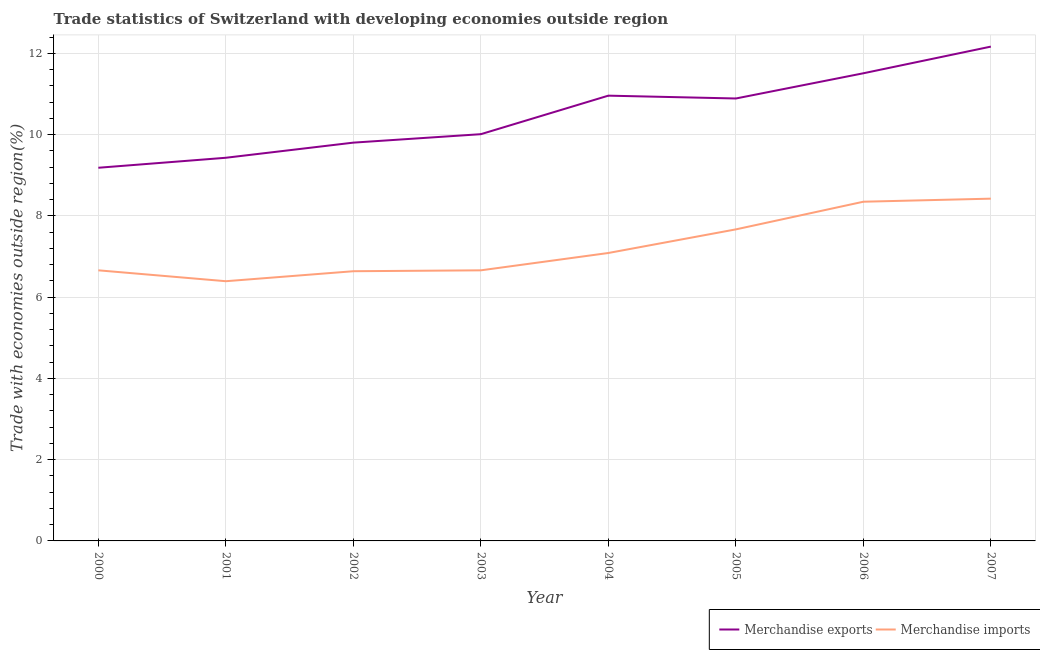Does the line corresponding to merchandise exports intersect with the line corresponding to merchandise imports?
Offer a terse response. No. Is the number of lines equal to the number of legend labels?
Make the answer very short. Yes. What is the merchandise exports in 2006?
Keep it short and to the point. 11.51. Across all years, what is the maximum merchandise exports?
Provide a succinct answer. 12.17. Across all years, what is the minimum merchandise imports?
Offer a very short reply. 6.39. In which year was the merchandise imports maximum?
Provide a succinct answer. 2007. In which year was the merchandise exports minimum?
Provide a short and direct response. 2000. What is the total merchandise exports in the graph?
Offer a very short reply. 83.96. What is the difference between the merchandise imports in 2000 and that in 2002?
Keep it short and to the point. 0.02. What is the difference between the merchandise exports in 2003 and the merchandise imports in 2006?
Offer a terse response. 1.66. What is the average merchandise exports per year?
Keep it short and to the point. 10.49. In the year 2004, what is the difference between the merchandise imports and merchandise exports?
Make the answer very short. -3.87. In how many years, is the merchandise exports greater than 7.2 %?
Ensure brevity in your answer.  8. What is the ratio of the merchandise exports in 2005 to that in 2007?
Your response must be concise. 0.9. What is the difference between the highest and the second highest merchandise exports?
Offer a terse response. 0.66. What is the difference between the highest and the lowest merchandise imports?
Provide a short and direct response. 2.03. In how many years, is the merchandise imports greater than the average merchandise imports taken over all years?
Make the answer very short. 3. Is the sum of the merchandise exports in 2001 and 2007 greater than the maximum merchandise imports across all years?
Your answer should be compact. Yes. Is the merchandise exports strictly greater than the merchandise imports over the years?
Offer a terse response. Yes. How many lines are there?
Your response must be concise. 2. How many years are there in the graph?
Ensure brevity in your answer.  8. What is the title of the graph?
Make the answer very short. Trade statistics of Switzerland with developing economies outside region. What is the label or title of the X-axis?
Your answer should be compact. Year. What is the label or title of the Y-axis?
Your answer should be compact. Trade with economies outside region(%). What is the Trade with economies outside region(%) in Merchandise exports in 2000?
Offer a terse response. 9.18. What is the Trade with economies outside region(%) in Merchandise imports in 2000?
Ensure brevity in your answer.  6.66. What is the Trade with economies outside region(%) in Merchandise exports in 2001?
Your answer should be compact. 9.43. What is the Trade with economies outside region(%) in Merchandise imports in 2001?
Provide a short and direct response. 6.39. What is the Trade with economies outside region(%) of Merchandise exports in 2002?
Give a very brief answer. 9.8. What is the Trade with economies outside region(%) in Merchandise imports in 2002?
Make the answer very short. 6.64. What is the Trade with economies outside region(%) of Merchandise exports in 2003?
Ensure brevity in your answer.  10.01. What is the Trade with economies outside region(%) in Merchandise imports in 2003?
Your answer should be very brief. 6.66. What is the Trade with economies outside region(%) in Merchandise exports in 2004?
Make the answer very short. 10.96. What is the Trade with economies outside region(%) of Merchandise imports in 2004?
Your answer should be compact. 7.09. What is the Trade with economies outside region(%) in Merchandise exports in 2005?
Provide a short and direct response. 10.89. What is the Trade with economies outside region(%) of Merchandise imports in 2005?
Your response must be concise. 7.67. What is the Trade with economies outside region(%) in Merchandise exports in 2006?
Your answer should be very brief. 11.51. What is the Trade with economies outside region(%) in Merchandise imports in 2006?
Provide a short and direct response. 8.35. What is the Trade with economies outside region(%) in Merchandise exports in 2007?
Make the answer very short. 12.17. What is the Trade with economies outside region(%) of Merchandise imports in 2007?
Offer a terse response. 8.42. Across all years, what is the maximum Trade with economies outside region(%) in Merchandise exports?
Keep it short and to the point. 12.17. Across all years, what is the maximum Trade with economies outside region(%) in Merchandise imports?
Give a very brief answer. 8.42. Across all years, what is the minimum Trade with economies outside region(%) in Merchandise exports?
Provide a short and direct response. 9.18. Across all years, what is the minimum Trade with economies outside region(%) of Merchandise imports?
Offer a terse response. 6.39. What is the total Trade with economies outside region(%) of Merchandise exports in the graph?
Provide a short and direct response. 83.96. What is the total Trade with economies outside region(%) in Merchandise imports in the graph?
Offer a very short reply. 57.88. What is the difference between the Trade with economies outside region(%) of Merchandise exports in 2000 and that in 2001?
Make the answer very short. -0.25. What is the difference between the Trade with economies outside region(%) of Merchandise imports in 2000 and that in 2001?
Provide a short and direct response. 0.27. What is the difference between the Trade with economies outside region(%) in Merchandise exports in 2000 and that in 2002?
Your answer should be very brief. -0.62. What is the difference between the Trade with economies outside region(%) in Merchandise imports in 2000 and that in 2002?
Your answer should be very brief. 0.02. What is the difference between the Trade with economies outside region(%) in Merchandise exports in 2000 and that in 2003?
Keep it short and to the point. -0.83. What is the difference between the Trade with economies outside region(%) of Merchandise exports in 2000 and that in 2004?
Your answer should be very brief. -1.77. What is the difference between the Trade with economies outside region(%) of Merchandise imports in 2000 and that in 2004?
Offer a very short reply. -0.43. What is the difference between the Trade with economies outside region(%) of Merchandise exports in 2000 and that in 2005?
Provide a short and direct response. -1.71. What is the difference between the Trade with economies outside region(%) in Merchandise imports in 2000 and that in 2005?
Give a very brief answer. -1.01. What is the difference between the Trade with economies outside region(%) in Merchandise exports in 2000 and that in 2006?
Your answer should be compact. -2.33. What is the difference between the Trade with economies outside region(%) of Merchandise imports in 2000 and that in 2006?
Your response must be concise. -1.69. What is the difference between the Trade with economies outside region(%) of Merchandise exports in 2000 and that in 2007?
Make the answer very short. -2.98. What is the difference between the Trade with economies outside region(%) of Merchandise imports in 2000 and that in 2007?
Provide a short and direct response. -1.76. What is the difference between the Trade with economies outside region(%) in Merchandise exports in 2001 and that in 2002?
Offer a very short reply. -0.37. What is the difference between the Trade with economies outside region(%) in Merchandise imports in 2001 and that in 2002?
Your answer should be compact. -0.25. What is the difference between the Trade with economies outside region(%) in Merchandise exports in 2001 and that in 2003?
Keep it short and to the point. -0.58. What is the difference between the Trade with economies outside region(%) in Merchandise imports in 2001 and that in 2003?
Give a very brief answer. -0.27. What is the difference between the Trade with economies outside region(%) of Merchandise exports in 2001 and that in 2004?
Give a very brief answer. -1.53. What is the difference between the Trade with economies outside region(%) of Merchandise imports in 2001 and that in 2004?
Make the answer very short. -0.69. What is the difference between the Trade with economies outside region(%) in Merchandise exports in 2001 and that in 2005?
Your response must be concise. -1.46. What is the difference between the Trade with economies outside region(%) in Merchandise imports in 2001 and that in 2005?
Offer a terse response. -1.28. What is the difference between the Trade with economies outside region(%) of Merchandise exports in 2001 and that in 2006?
Provide a short and direct response. -2.08. What is the difference between the Trade with economies outside region(%) in Merchandise imports in 2001 and that in 2006?
Keep it short and to the point. -1.96. What is the difference between the Trade with economies outside region(%) of Merchandise exports in 2001 and that in 2007?
Your answer should be compact. -2.74. What is the difference between the Trade with economies outside region(%) of Merchandise imports in 2001 and that in 2007?
Make the answer very short. -2.03. What is the difference between the Trade with economies outside region(%) in Merchandise exports in 2002 and that in 2003?
Your response must be concise. -0.21. What is the difference between the Trade with economies outside region(%) in Merchandise imports in 2002 and that in 2003?
Ensure brevity in your answer.  -0.02. What is the difference between the Trade with economies outside region(%) of Merchandise exports in 2002 and that in 2004?
Provide a succinct answer. -1.16. What is the difference between the Trade with economies outside region(%) of Merchandise imports in 2002 and that in 2004?
Offer a very short reply. -0.45. What is the difference between the Trade with economies outside region(%) in Merchandise exports in 2002 and that in 2005?
Your answer should be very brief. -1.09. What is the difference between the Trade with economies outside region(%) in Merchandise imports in 2002 and that in 2005?
Give a very brief answer. -1.03. What is the difference between the Trade with economies outside region(%) of Merchandise exports in 2002 and that in 2006?
Your answer should be very brief. -1.71. What is the difference between the Trade with economies outside region(%) of Merchandise imports in 2002 and that in 2006?
Provide a short and direct response. -1.71. What is the difference between the Trade with economies outside region(%) of Merchandise exports in 2002 and that in 2007?
Your answer should be compact. -2.36. What is the difference between the Trade with economies outside region(%) of Merchandise imports in 2002 and that in 2007?
Offer a very short reply. -1.79. What is the difference between the Trade with economies outside region(%) in Merchandise exports in 2003 and that in 2004?
Your response must be concise. -0.95. What is the difference between the Trade with economies outside region(%) of Merchandise imports in 2003 and that in 2004?
Provide a succinct answer. -0.43. What is the difference between the Trade with economies outside region(%) in Merchandise exports in 2003 and that in 2005?
Your answer should be compact. -0.88. What is the difference between the Trade with economies outside region(%) in Merchandise imports in 2003 and that in 2005?
Offer a terse response. -1.01. What is the difference between the Trade with economies outside region(%) in Merchandise exports in 2003 and that in 2006?
Ensure brevity in your answer.  -1.5. What is the difference between the Trade with economies outside region(%) of Merchandise imports in 2003 and that in 2006?
Your answer should be very brief. -1.69. What is the difference between the Trade with economies outside region(%) in Merchandise exports in 2003 and that in 2007?
Ensure brevity in your answer.  -2.16. What is the difference between the Trade with economies outside region(%) in Merchandise imports in 2003 and that in 2007?
Provide a short and direct response. -1.76. What is the difference between the Trade with economies outside region(%) of Merchandise exports in 2004 and that in 2005?
Make the answer very short. 0.07. What is the difference between the Trade with economies outside region(%) in Merchandise imports in 2004 and that in 2005?
Give a very brief answer. -0.58. What is the difference between the Trade with economies outside region(%) in Merchandise exports in 2004 and that in 2006?
Offer a terse response. -0.55. What is the difference between the Trade with economies outside region(%) of Merchandise imports in 2004 and that in 2006?
Offer a terse response. -1.26. What is the difference between the Trade with economies outside region(%) in Merchandise exports in 2004 and that in 2007?
Keep it short and to the point. -1.21. What is the difference between the Trade with economies outside region(%) of Merchandise imports in 2004 and that in 2007?
Ensure brevity in your answer.  -1.34. What is the difference between the Trade with economies outside region(%) in Merchandise exports in 2005 and that in 2006?
Your response must be concise. -0.62. What is the difference between the Trade with economies outside region(%) of Merchandise imports in 2005 and that in 2006?
Your answer should be very brief. -0.68. What is the difference between the Trade with economies outside region(%) of Merchandise exports in 2005 and that in 2007?
Offer a terse response. -1.28. What is the difference between the Trade with economies outside region(%) of Merchandise imports in 2005 and that in 2007?
Your answer should be very brief. -0.76. What is the difference between the Trade with economies outside region(%) in Merchandise exports in 2006 and that in 2007?
Ensure brevity in your answer.  -0.66. What is the difference between the Trade with economies outside region(%) in Merchandise imports in 2006 and that in 2007?
Your answer should be very brief. -0.08. What is the difference between the Trade with economies outside region(%) of Merchandise exports in 2000 and the Trade with economies outside region(%) of Merchandise imports in 2001?
Offer a terse response. 2.79. What is the difference between the Trade with economies outside region(%) in Merchandise exports in 2000 and the Trade with economies outside region(%) in Merchandise imports in 2002?
Offer a very short reply. 2.55. What is the difference between the Trade with economies outside region(%) of Merchandise exports in 2000 and the Trade with economies outside region(%) of Merchandise imports in 2003?
Offer a very short reply. 2.52. What is the difference between the Trade with economies outside region(%) of Merchandise exports in 2000 and the Trade with economies outside region(%) of Merchandise imports in 2004?
Provide a succinct answer. 2.1. What is the difference between the Trade with economies outside region(%) of Merchandise exports in 2000 and the Trade with economies outside region(%) of Merchandise imports in 2005?
Ensure brevity in your answer.  1.52. What is the difference between the Trade with economies outside region(%) in Merchandise exports in 2000 and the Trade with economies outside region(%) in Merchandise imports in 2006?
Ensure brevity in your answer.  0.84. What is the difference between the Trade with economies outside region(%) in Merchandise exports in 2000 and the Trade with economies outside region(%) in Merchandise imports in 2007?
Your answer should be very brief. 0.76. What is the difference between the Trade with economies outside region(%) in Merchandise exports in 2001 and the Trade with economies outside region(%) in Merchandise imports in 2002?
Offer a terse response. 2.79. What is the difference between the Trade with economies outside region(%) of Merchandise exports in 2001 and the Trade with economies outside region(%) of Merchandise imports in 2003?
Keep it short and to the point. 2.77. What is the difference between the Trade with economies outside region(%) in Merchandise exports in 2001 and the Trade with economies outside region(%) in Merchandise imports in 2004?
Provide a succinct answer. 2.34. What is the difference between the Trade with economies outside region(%) of Merchandise exports in 2001 and the Trade with economies outside region(%) of Merchandise imports in 2005?
Ensure brevity in your answer.  1.76. What is the difference between the Trade with economies outside region(%) of Merchandise exports in 2001 and the Trade with economies outside region(%) of Merchandise imports in 2006?
Offer a very short reply. 1.08. What is the difference between the Trade with economies outside region(%) of Merchandise exports in 2001 and the Trade with economies outside region(%) of Merchandise imports in 2007?
Offer a terse response. 1.01. What is the difference between the Trade with economies outside region(%) of Merchandise exports in 2002 and the Trade with economies outside region(%) of Merchandise imports in 2003?
Give a very brief answer. 3.14. What is the difference between the Trade with economies outside region(%) in Merchandise exports in 2002 and the Trade with economies outside region(%) in Merchandise imports in 2004?
Provide a succinct answer. 2.72. What is the difference between the Trade with economies outside region(%) of Merchandise exports in 2002 and the Trade with economies outside region(%) of Merchandise imports in 2005?
Your answer should be compact. 2.14. What is the difference between the Trade with economies outside region(%) of Merchandise exports in 2002 and the Trade with economies outside region(%) of Merchandise imports in 2006?
Your answer should be compact. 1.45. What is the difference between the Trade with economies outside region(%) of Merchandise exports in 2002 and the Trade with economies outside region(%) of Merchandise imports in 2007?
Keep it short and to the point. 1.38. What is the difference between the Trade with economies outside region(%) in Merchandise exports in 2003 and the Trade with economies outside region(%) in Merchandise imports in 2004?
Your response must be concise. 2.92. What is the difference between the Trade with economies outside region(%) in Merchandise exports in 2003 and the Trade with economies outside region(%) in Merchandise imports in 2005?
Offer a very short reply. 2.34. What is the difference between the Trade with economies outside region(%) in Merchandise exports in 2003 and the Trade with economies outside region(%) in Merchandise imports in 2006?
Keep it short and to the point. 1.66. What is the difference between the Trade with economies outside region(%) of Merchandise exports in 2003 and the Trade with economies outside region(%) of Merchandise imports in 2007?
Ensure brevity in your answer.  1.59. What is the difference between the Trade with economies outside region(%) of Merchandise exports in 2004 and the Trade with economies outside region(%) of Merchandise imports in 2005?
Offer a very short reply. 3.29. What is the difference between the Trade with economies outside region(%) of Merchandise exports in 2004 and the Trade with economies outside region(%) of Merchandise imports in 2006?
Give a very brief answer. 2.61. What is the difference between the Trade with economies outside region(%) in Merchandise exports in 2004 and the Trade with economies outside region(%) in Merchandise imports in 2007?
Offer a terse response. 2.54. What is the difference between the Trade with economies outside region(%) in Merchandise exports in 2005 and the Trade with economies outside region(%) in Merchandise imports in 2006?
Offer a terse response. 2.54. What is the difference between the Trade with economies outside region(%) in Merchandise exports in 2005 and the Trade with economies outside region(%) in Merchandise imports in 2007?
Offer a terse response. 2.47. What is the difference between the Trade with economies outside region(%) in Merchandise exports in 2006 and the Trade with economies outside region(%) in Merchandise imports in 2007?
Your response must be concise. 3.09. What is the average Trade with economies outside region(%) of Merchandise exports per year?
Keep it short and to the point. 10.49. What is the average Trade with economies outside region(%) in Merchandise imports per year?
Your answer should be very brief. 7.23. In the year 2000, what is the difference between the Trade with economies outside region(%) of Merchandise exports and Trade with economies outside region(%) of Merchandise imports?
Your answer should be compact. 2.52. In the year 2001, what is the difference between the Trade with economies outside region(%) of Merchandise exports and Trade with economies outside region(%) of Merchandise imports?
Your response must be concise. 3.04. In the year 2002, what is the difference between the Trade with economies outside region(%) in Merchandise exports and Trade with economies outside region(%) in Merchandise imports?
Offer a very short reply. 3.17. In the year 2003, what is the difference between the Trade with economies outside region(%) in Merchandise exports and Trade with economies outside region(%) in Merchandise imports?
Provide a short and direct response. 3.35. In the year 2004, what is the difference between the Trade with economies outside region(%) in Merchandise exports and Trade with economies outside region(%) in Merchandise imports?
Make the answer very short. 3.87. In the year 2005, what is the difference between the Trade with economies outside region(%) in Merchandise exports and Trade with economies outside region(%) in Merchandise imports?
Your answer should be compact. 3.22. In the year 2006, what is the difference between the Trade with economies outside region(%) in Merchandise exports and Trade with economies outside region(%) in Merchandise imports?
Provide a short and direct response. 3.16. In the year 2007, what is the difference between the Trade with economies outside region(%) of Merchandise exports and Trade with economies outside region(%) of Merchandise imports?
Give a very brief answer. 3.74. What is the ratio of the Trade with economies outside region(%) of Merchandise exports in 2000 to that in 2001?
Provide a succinct answer. 0.97. What is the ratio of the Trade with economies outside region(%) of Merchandise imports in 2000 to that in 2001?
Give a very brief answer. 1.04. What is the ratio of the Trade with economies outside region(%) of Merchandise exports in 2000 to that in 2002?
Your answer should be compact. 0.94. What is the ratio of the Trade with economies outside region(%) of Merchandise imports in 2000 to that in 2002?
Your answer should be compact. 1. What is the ratio of the Trade with economies outside region(%) in Merchandise exports in 2000 to that in 2003?
Your response must be concise. 0.92. What is the ratio of the Trade with economies outside region(%) of Merchandise imports in 2000 to that in 2003?
Provide a short and direct response. 1. What is the ratio of the Trade with economies outside region(%) in Merchandise exports in 2000 to that in 2004?
Provide a succinct answer. 0.84. What is the ratio of the Trade with economies outside region(%) in Merchandise imports in 2000 to that in 2004?
Give a very brief answer. 0.94. What is the ratio of the Trade with economies outside region(%) in Merchandise exports in 2000 to that in 2005?
Provide a short and direct response. 0.84. What is the ratio of the Trade with economies outside region(%) of Merchandise imports in 2000 to that in 2005?
Your response must be concise. 0.87. What is the ratio of the Trade with economies outside region(%) of Merchandise exports in 2000 to that in 2006?
Your answer should be very brief. 0.8. What is the ratio of the Trade with economies outside region(%) in Merchandise imports in 2000 to that in 2006?
Offer a terse response. 0.8. What is the ratio of the Trade with economies outside region(%) in Merchandise exports in 2000 to that in 2007?
Ensure brevity in your answer.  0.75. What is the ratio of the Trade with economies outside region(%) in Merchandise imports in 2000 to that in 2007?
Your response must be concise. 0.79. What is the ratio of the Trade with economies outside region(%) in Merchandise exports in 2001 to that in 2003?
Your answer should be compact. 0.94. What is the ratio of the Trade with economies outside region(%) of Merchandise imports in 2001 to that in 2003?
Provide a succinct answer. 0.96. What is the ratio of the Trade with economies outside region(%) of Merchandise exports in 2001 to that in 2004?
Provide a short and direct response. 0.86. What is the ratio of the Trade with economies outside region(%) of Merchandise imports in 2001 to that in 2004?
Your response must be concise. 0.9. What is the ratio of the Trade with economies outside region(%) of Merchandise exports in 2001 to that in 2005?
Your answer should be very brief. 0.87. What is the ratio of the Trade with economies outside region(%) of Merchandise imports in 2001 to that in 2005?
Ensure brevity in your answer.  0.83. What is the ratio of the Trade with economies outside region(%) in Merchandise exports in 2001 to that in 2006?
Give a very brief answer. 0.82. What is the ratio of the Trade with economies outside region(%) in Merchandise imports in 2001 to that in 2006?
Your response must be concise. 0.77. What is the ratio of the Trade with economies outside region(%) of Merchandise exports in 2001 to that in 2007?
Your answer should be compact. 0.78. What is the ratio of the Trade with economies outside region(%) of Merchandise imports in 2001 to that in 2007?
Ensure brevity in your answer.  0.76. What is the ratio of the Trade with economies outside region(%) in Merchandise exports in 2002 to that in 2003?
Your answer should be very brief. 0.98. What is the ratio of the Trade with economies outside region(%) of Merchandise exports in 2002 to that in 2004?
Keep it short and to the point. 0.89. What is the ratio of the Trade with economies outside region(%) in Merchandise imports in 2002 to that in 2004?
Provide a short and direct response. 0.94. What is the ratio of the Trade with economies outside region(%) in Merchandise exports in 2002 to that in 2005?
Ensure brevity in your answer.  0.9. What is the ratio of the Trade with economies outside region(%) in Merchandise imports in 2002 to that in 2005?
Your answer should be very brief. 0.87. What is the ratio of the Trade with economies outside region(%) in Merchandise exports in 2002 to that in 2006?
Offer a terse response. 0.85. What is the ratio of the Trade with economies outside region(%) of Merchandise imports in 2002 to that in 2006?
Keep it short and to the point. 0.8. What is the ratio of the Trade with economies outside region(%) in Merchandise exports in 2002 to that in 2007?
Provide a succinct answer. 0.81. What is the ratio of the Trade with economies outside region(%) in Merchandise imports in 2002 to that in 2007?
Ensure brevity in your answer.  0.79. What is the ratio of the Trade with economies outside region(%) in Merchandise exports in 2003 to that in 2004?
Provide a succinct answer. 0.91. What is the ratio of the Trade with economies outside region(%) in Merchandise imports in 2003 to that in 2004?
Your answer should be compact. 0.94. What is the ratio of the Trade with economies outside region(%) in Merchandise exports in 2003 to that in 2005?
Give a very brief answer. 0.92. What is the ratio of the Trade with economies outside region(%) of Merchandise imports in 2003 to that in 2005?
Ensure brevity in your answer.  0.87. What is the ratio of the Trade with economies outside region(%) in Merchandise exports in 2003 to that in 2006?
Offer a terse response. 0.87. What is the ratio of the Trade with economies outside region(%) in Merchandise imports in 2003 to that in 2006?
Your answer should be compact. 0.8. What is the ratio of the Trade with economies outside region(%) of Merchandise exports in 2003 to that in 2007?
Offer a very short reply. 0.82. What is the ratio of the Trade with economies outside region(%) in Merchandise imports in 2003 to that in 2007?
Provide a succinct answer. 0.79. What is the ratio of the Trade with economies outside region(%) in Merchandise exports in 2004 to that in 2005?
Keep it short and to the point. 1.01. What is the ratio of the Trade with economies outside region(%) of Merchandise imports in 2004 to that in 2005?
Offer a terse response. 0.92. What is the ratio of the Trade with economies outside region(%) in Merchandise exports in 2004 to that in 2006?
Make the answer very short. 0.95. What is the ratio of the Trade with economies outside region(%) in Merchandise imports in 2004 to that in 2006?
Offer a terse response. 0.85. What is the ratio of the Trade with economies outside region(%) of Merchandise exports in 2004 to that in 2007?
Make the answer very short. 0.9. What is the ratio of the Trade with economies outside region(%) of Merchandise imports in 2004 to that in 2007?
Offer a terse response. 0.84. What is the ratio of the Trade with economies outside region(%) of Merchandise exports in 2005 to that in 2006?
Make the answer very short. 0.95. What is the ratio of the Trade with economies outside region(%) in Merchandise imports in 2005 to that in 2006?
Provide a succinct answer. 0.92. What is the ratio of the Trade with economies outside region(%) in Merchandise exports in 2005 to that in 2007?
Provide a succinct answer. 0.9. What is the ratio of the Trade with economies outside region(%) in Merchandise imports in 2005 to that in 2007?
Keep it short and to the point. 0.91. What is the ratio of the Trade with economies outside region(%) in Merchandise exports in 2006 to that in 2007?
Provide a succinct answer. 0.95. What is the difference between the highest and the second highest Trade with economies outside region(%) of Merchandise exports?
Provide a short and direct response. 0.66. What is the difference between the highest and the second highest Trade with economies outside region(%) in Merchandise imports?
Your answer should be very brief. 0.08. What is the difference between the highest and the lowest Trade with economies outside region(%) of Merchandise exports?
Give a very brief answer. 2.98. What is the difference between the highest and the lowest Trade with economies outside region(%) of Merchandise imports?
Offer a very short reply. 2.03. 